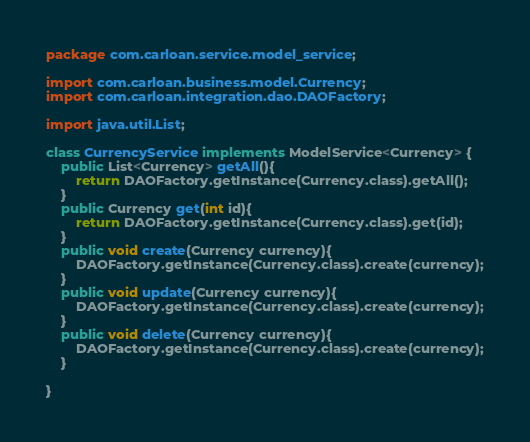Convert code to text. <code><loc_0><loc_0><loc_500><loc_500><_Java_>package com.carloan.service.model_service;

import com.carloan.business.model.Currency;
import com.carloan.integration.dao.DAOFactory;

import java.util.List;

class CurrencyService implements ModelService<Currency> {
    public List<Currency> getAll(){
        return DAOFactory.getInstance(Currency.class).getAll();
    }
    public Currency get(int id){
        return DAOFactory.getInstance(Currency.class).get(id);
    }
    public void create(Currency currency){
        DAOFactory.getInstance(Currency.class).create(currency);
    }
    public void update(Currency currency){
        DAOFactory.getInstance(Currency.class).create(currency);
    }
    public void delete(Currency currency){
        DAOFactory.getInstance(Currency.class).create(currency);
    }

}
</code> 